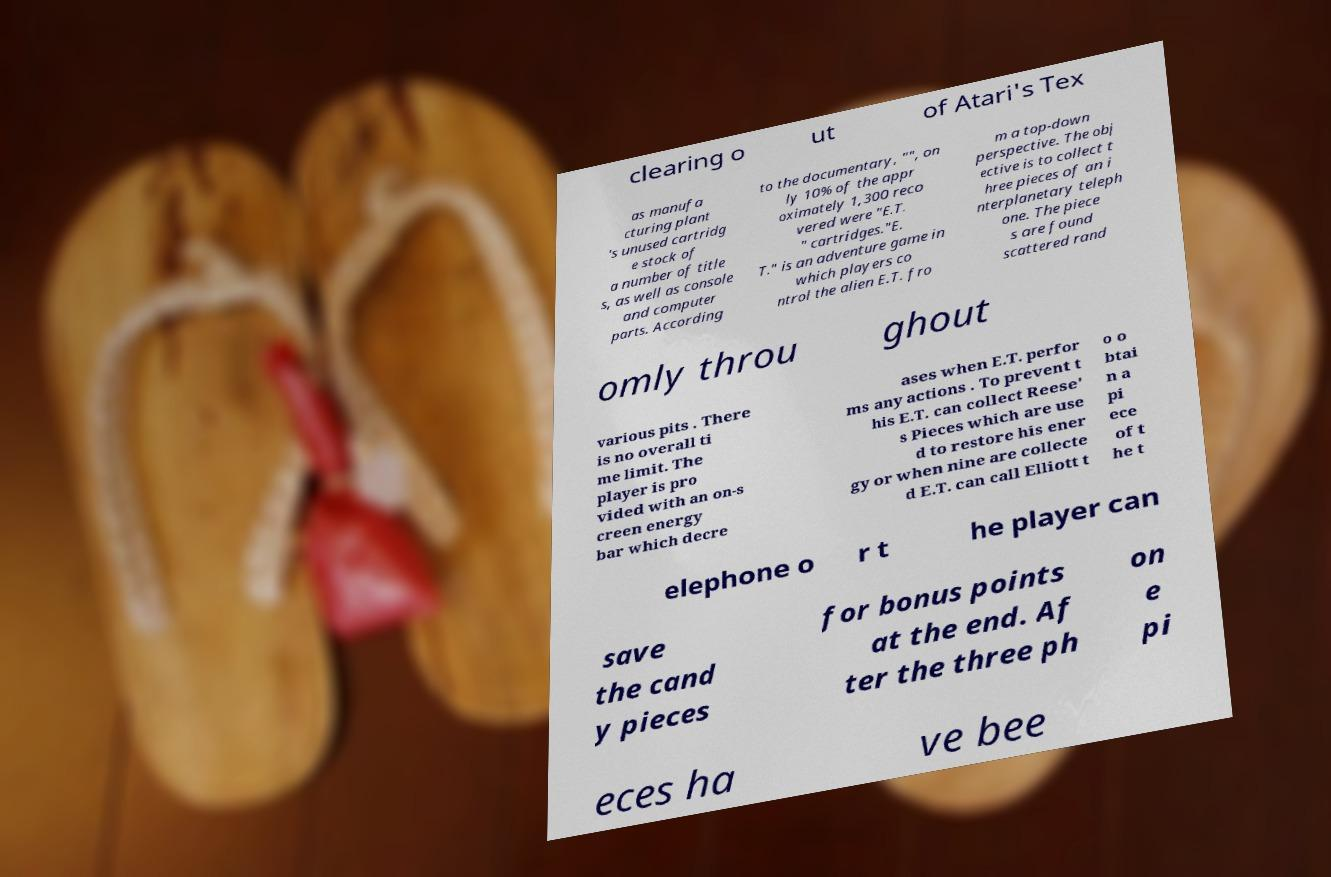Can you read and provide the text displayed in the image?This photo seems to have some interesting text. Can you extract and type it out for me? clearing o ut of Atari's Tex as manufa cturing plant 's unused cartridg e stock of a number of title s, as well as console and computer parts. According to the documentary, "", on ly 10% of the appr oximately 1,300 reco vered were "E.T. " cartridges."E. T." is an adventure game in which players co ntrol the alien E.T. fro m a top-down perspective. The obj ective is to collect t hree pieces of an i nterplanetary teleph one. The piece s are found scattered rand omly throu ghout various pits . There is no overall ti me limit. The player is pro vided with an on-s creen energy bar which decre ases when E.T. perfor ms any actions . To prevent t his E.T. can collect Reese' s Pieces which are use d to restore his ener gy or when nine are collecte d E.T. can call Elliott t o o btai n a pi ece of t he t elephone o r t he player can save the cand y pieces for bonus points at the end. Af ter the three ph on e pi eces ha ve bee 